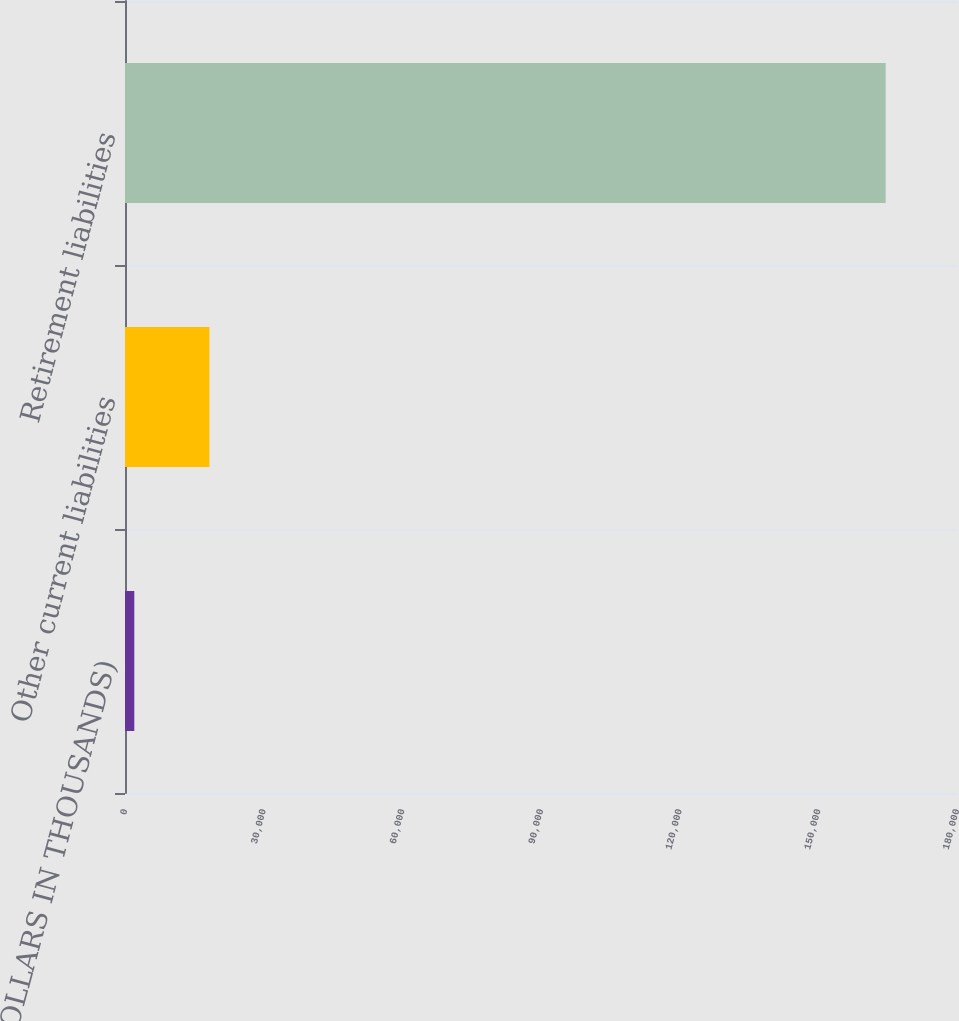Convert chart. <chart><loc_0><loc_0><loc_500><loc_500><bar_chart><fcel>(DOLLARS IN THOUSANDS)<fcel>Other current liabilities<fcel>Retirement liabilities<nl><fcel>2012<fcel>18267<fcel>164562<nl></chart> 